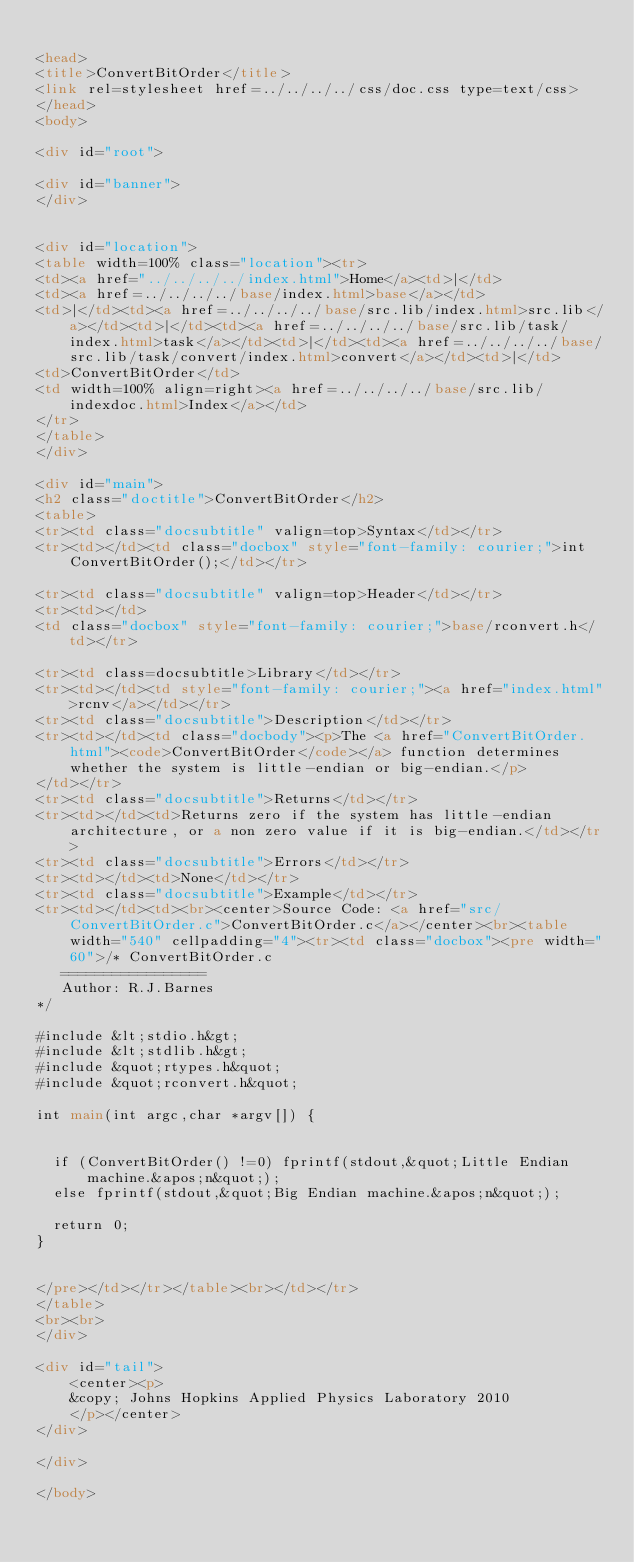<code> <loc_0><loc_0><loc_500><loc_500><_HTML_>
<head>
<title>ConvertBitOrder</title>
<link rel=stylesheet href=../../../../css/doc.css type=text/css>
</head>
<body>

<div id="root">

<div id="banner">
</div>


<div id="location">
<table width=100% class="location"><tr>
<td><a href="../../../../index.html">Home</a><td>|</td>
<td><a href=../../../../base/index.html>base</a></td>
<td>|</td><td><a href=../../../../base/src.lib/index.html>src.lib</a></td><td>|</td><td><a href=../../../../base/src.lib/task/index.html>task</a></td><td>|</td><td><a href=../../../../base/src.lib/task/convert/index.html>convert</a></td><td>|</td>
<td>ConvertBitOrder</td>
<td width=100% align=right><a href=../../../../base/src.lib/indexdoc.html>Index</a></td>
</tr>
</table>
</div>

<div id="main">
<h2 class="doctitle">ConvertBitOrder</h2>
<table>
<tr><td class="docsubtitle" valign=top>Syntax</td></tr>
<tr><td></td><td class="docbox" style="font-family: courier;">int ConvertBitOrder();</td></tr>

<tr><td class="docsubtitle" valign=top>Header</td></tr>
<tr><td></td>
<td class="docbox" style="font-family: courier;">base/rconvert.h</td></tr>

<tr><td class=docsubtitle>Library</td></tr>
<tr><td></td><td style="font-family: courier;"><a href="index.html">rcnv</a></td></tr>
<tr><td class="docsubtitle">Description</td></tr>
<tr><td></td><td class="docbody"><p>The <a href="ConvertBitOrder.html"><code>ConvertBitOrder</code></a> function determines whether the system is little-endian or big-endian.</p>
</td></tr>
<tr><td class="docsubtitle">Returns</td></tr>
<tr><td></td><td>Returns zero if the system has little-endian architecture, or a non zero value if it is big-endian.</td></tr>
<tr><td class="docsubtitle">Errors</td></tr>
<tr><td></td><td>None</td></tr>
<tr><td class="docsubtitle">Example</td></tr>
<tr><td></td><td><br><center>Source Code: <a href="src/ConvertBitOrder.c">ConvertBitOrder.c</a></center><br><table width="540" cellpadding="4"><tr><td class="docbox"><pre width="60">/* ConvertBitOrder.c
   ================= 
   Author: R.J.Barnes
*/

#include &lt;stdio.h&gt;
#include &lt;stdlib.h&gt;
#include &quot;rtypes.h&quot;
#include &quot;rconvert.h&quot;

int main(int argc,char *argv[]) {

  
  if (ConvertBitOrder() !=0) fprintf(stdout,&quot;Little Endian machine.&apos;n&quot;);
  else fprintf(stdout,&quot;Big Endian machine.&apos;n&quot;);

  return 0;
}
   

</pre></td></tr></table><br></td></tr>
</table>
<br><br>
</div>

<div id="tail">
    <center><p>
    &copy; Johns Hopkins Applied Physics Laboratory 2010
    </p></center>
</div>

</div>

</body>




</code> 